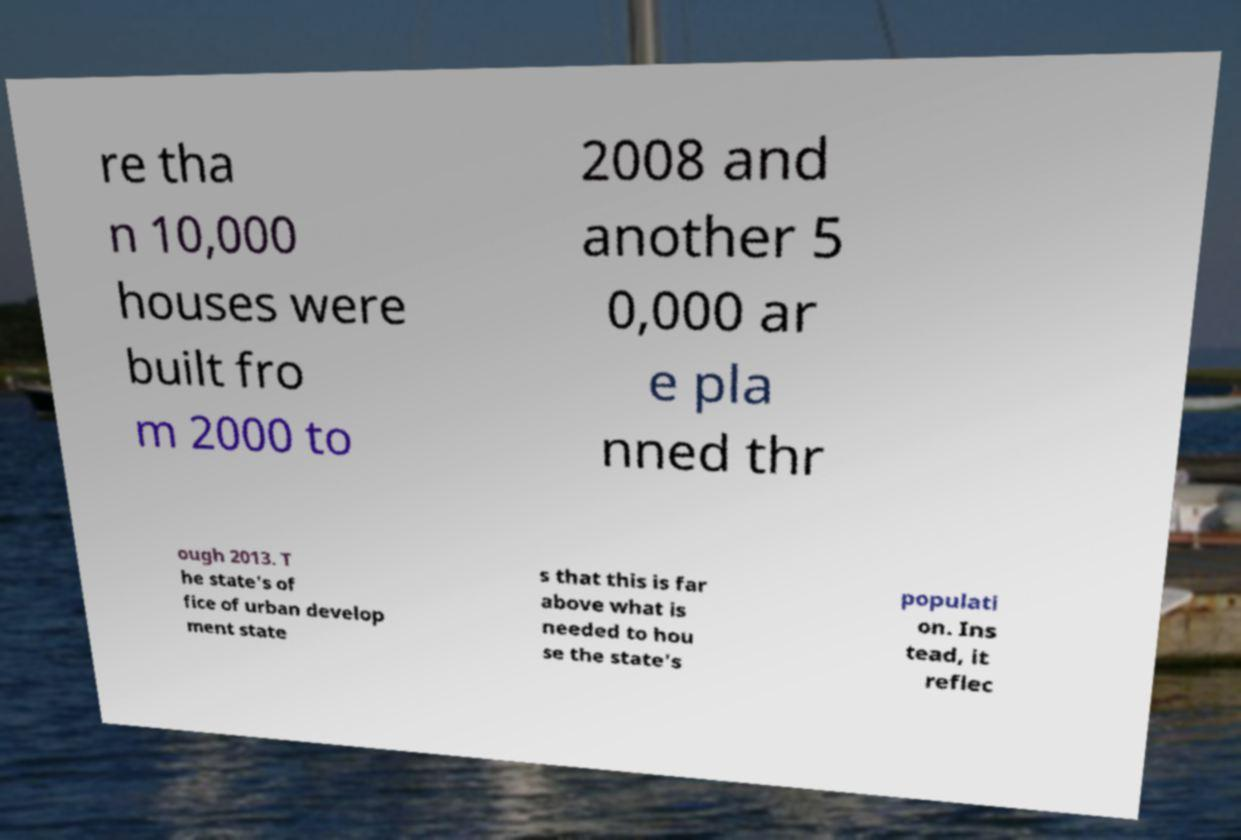Can you read and provide the text displayed in the image?This photo seems to have some interesting text. Can you extract and type it out for me? re tha n 10,000 houses were built fro m 2000 to 2008 and another 5 0,000 ar e pla nned thr ough 2013. T he state's of fice of urban develop ment state s that this is far above what is needed to hou se the state's populati on. Ins tead, it reflec 